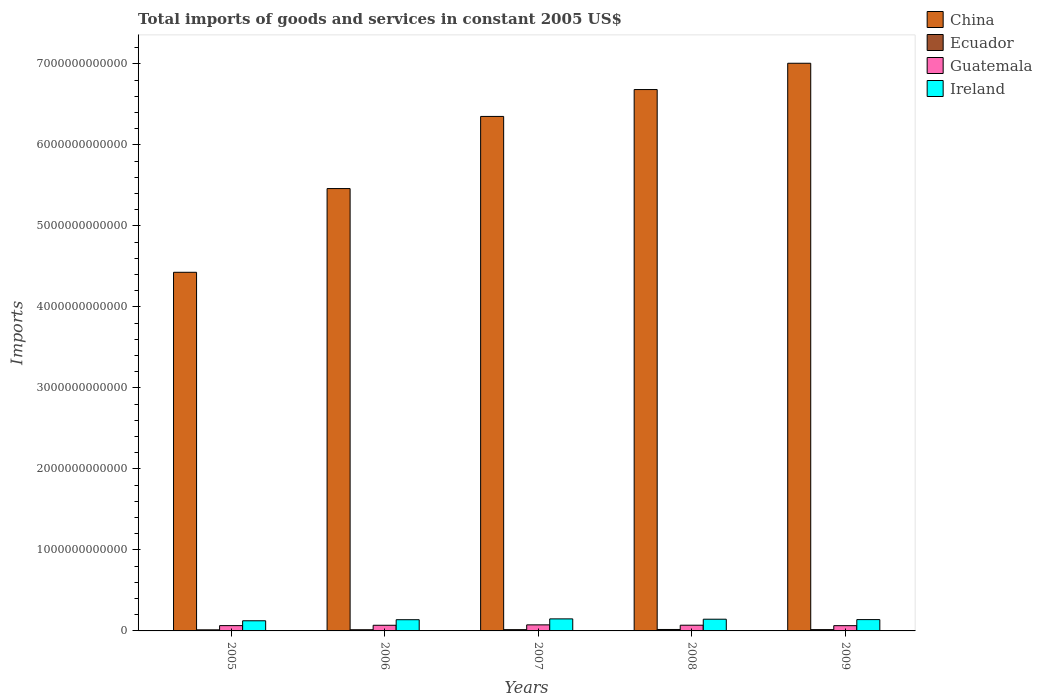How many different coloured bars are there?
Provide a succinct answer. 4. How many groups of bars are there?
Your answer should be very brief. 5. Are the number of bars per tick equal to the number of legend labels?
Make the answer very short. Yes. Are the number of bars on each tick of the X-axis equal?
Your answer should be compact. Yes. How many bars are there on the 3rd tick from the right?
Your answer should be very brief. 4. In how many cases, is the number of bars for a given year not equal to the number of legend labels?
Offer a very short reply. 0. What is the total imports of goods and services in Ecuador in 2005?
Provide a succinct answer. 1.33e+1. Across all years, what is the maximum total imports of goods and services in Guatemala?
Your answer should be very brief. 7.47e+1. Across all years, what is the minimum total imports of goods and services in Ireland?
Provide a short and direct response. 1.25e+11. In which year was the total imports of goods and services in Ireland maximum?
Make the answer very short. 2007. What is the total total imports of goods and services in Guatemala in the graph?
Your response must be concise. 3.45e+11. What is the difference between the total imports of goods and services in Ireland in 2008 and that in 2009?
Keep it short and to the point. 4.70e+09. What is the difference between the total imports of goods and services in China in 2007 and the total imports of goods and services in Ecuador in 2005?
Provide a succinct answer. 6.34e+12. What is the average total imports of goods and services in Ireland per year?
Keep it short and to the point. 1.39e+11. In the year 2009, what is the difference between the total imports of goods and services in China and total imports of goods and services in Ireland?
Offer a terse response. 6.87e+12. In how many years, is the total imports of goods and services in Ireland greater than 3000000000000 US$?
Ensure brevity in your answer.  0. What is the ratio of the total imports of goods and services in Ireland in 2006 to that in 2009?
Your answer should be compact. 0.99. Is the difference between the total imports of goods and services in China in 2007 and 2008 greater than the difference between the total imports of goods and services in Ireland in 2007 and 2008?
Ensure brevity in your answer.  No. What is the difference between the highest and the second highest total imports of goods and services in Ireland?
Give a very brief answer. 4.06e+09. What is the difference between the highest and the lowest total imports of goods and services in China?
Provide a succinct answer. 2.58e+12. In how many years, is the total imports of goods and services in Ireland greater than the average total imports of goods and services in Ireland taken over all years?
Offer a terse response. 3. Is the sum of the total imports of goods and services in Ecuador in 2005 and 2008 greater than the maximum total imports of goods and services in Ireland across all years?
Your answer should be very brief. No. What does the 4th bar from the right in 2009 represents?
Your response must be concise. China. Are all the bars in the graph horizontal?
Keep it short and to the point. No. What is the difference between two consecutive major ticks on the Y-axis?
Offer a very short reply. 1.00e+12. Are the values on the major ticks of Y-axis written in scientific E-notation?
Offer a very short reply. No. Where does the legend appear in the graph?
Provide a short and direct response. Top right. How many legend labels are there?
Keep it short and to the point. 4. What is the title of the graph?
Provide a short and direct response. Total imports of goods and services in constant 2005 US$. Does "Colombia" appear as one of the legend labels in the graph?
Give a very brief answer. No. What is the label or title of the Y-axis?
Make the answer very short. Imports. What is the Imports of China in 2005?
Give a very brief answer. 4.43e+12. What is the Imports in Ecuador in 2005?
Your answer should be very brief. 1.33e+1. What is the Imports in Guatemala in 2005?
Ensure brevity in your answer.  6.55e+1. What is the Imports in Ireland in 2005?
Your response must be concise. 1.25e+11. What is the Imports of China in 2006?
Provide a succinct answer. 5.46e+12. What is the Imports in Ecuador in 2006?
Ensure brevity in your answer.  1.46e+1. What is the Imports in Guatemala in 2006?
Keep it short and to the point. 6.97e+1. What is the Imports in Ireland in 2006?
Provide a succinct answer. 1.38e+11. What is the Imports in China in 2007?
Provide a succinct answer. 6.35e+12. What is the Imports in Ecuador in 2007?
Your response must be concise. 1.56e+1. What is the Imports in Guatemala in 2007?
Offer a very short reply. 7.47e+1. What is the Imports of Ireland in 2007?
Keep it short and to the point. 1.49e+11. What is the Imports of China in 2008?
Make the answer very short. 6.68e+12. What is the Imports of Ecuador in 2008?
Keep it short and to the point. 1.79e+1. What is the Imports of Guatemala in 2008?
Your answer should be very brief. 7.04e+1. What is the Imports in Ireland in 2008?
Keep it short and to the point. 1.44e+11. What is the Imports in China in 2009?
Your response must be concise. 7.01e+12. What is the Imports in Ecuador in 2009?
Your response must be concise. 1.61e+1. What is the Imports of Guatemala in 2009?
Your answer should be very brief. 6.49e+1. What is the Imports of Ireland in 2009?
Offer a very short reply. 1.40e+11. Across all years, what is the maximum Imports in China?
Ensure brevity in your answer.  7.01e+12. Across all years, what is the maximum Imports in Ecuador?
Keep it short and to the point. 1.79e+1. Across all years, what is the maximum Imports of Guatemala?
Make the answer very short. 7.47e+1. Across all years, what is the maximum Imports of Ireland?
Give a very brief answer. 1.49e+11. Across all years, what is the minimum Imports of China?
Your answer should be compact. 4.43e+12. Across all years, what is the minimum Imports of Ecuador?
Offer a terse response. 1.33e+1. Across all years, what is the minimum Imports in Guatemala?
Provide a short and direct response. 6.49e+1. Across all years, what is the minimum Imports of Ireland?
Provide a succinct answer. 1.25e+11. What is the total Imports of China in the graph?
Your answer should be compact. 2.99e+13. What is the total Imports in Ecuador in the graph?
Your answer should be compact. 7.76e+1. What is the total Imports in Guatemala in the graph?
Keep it short and to the point. 3.45e+11. What is the total Imports of Ireland in the graph?
Your response must be concise. 6.96e+11. What is the difference between the Imports in China in 2005 and that in 2006?
Offer a very short reply. -1.03e+12. What is the difference between the Imports of Ecuador in 2005 and that in 2006?
Offer a terse response. -1.30e+09. What is the difference between the Imports in Guatemala in 2005 and that in 2006?
Your answer should be compact. -4.22e+09. What is the difference between the Imports of Ireland in 2005 and that in 2006?
Make the answer very short. -1.32e+1. What is the difference between the Imports in China in 2005 and that in 2007?
Make the answer very short. -1.92e+12. What is the difference between the Imports in Ecuador in 2005 and that in 2007?
Make the answer very short. -2.33e+09. What is the difference between the Imports in Guatemala in 2005 and that in 2007?
Provide a succinct answer. -9.26e+09. What is the difference between the Imports in Ireland in 2005 and that in 2007?
Give a very brief answer. -2.34e+1. What is the difference between the Imports in China in 2005 and that in 2008?
Your answer should be very brief. -2.26e+12. What is the difference between the Imports of Ecuador in 2005 and that in 2008?
Provide a short and direct response. -4.59e+09. What is the difference between the Imports in Guatemala in 2005 and that in 2008?
Make the answer very short. -4.97e+09. What is the difference between the Imports in Ireland in 2005 and that in 2008?
Keep it short and to the point. -1.93e+1. What is the difference between the Imports in China in 2005 and that in 2009?
Your response must be concise. -2.58e+12. What is the difference between the Imports of Ecuador in 2005 and that in 2009?
Keep it short and to the point. -2.81e+09. What is the difference between the Imports of Guatemala in 2005 and that in 2009?
Your answer should be compact. 5.25e+08. What is the difference between the Imports of Ireland in 2005 and that in 2009?
Provide a short and direct response. -1.46e+1. What is the difference between the Imports of China in 2006 and that in 2007?
Provide a succinct answer. -8.91e+11. What is the difference between the Imports of Ecuador in 2006 and that in 2007?
Keep it short and to the point. -1.03e+09. What is the difference between the Imports of Guatemala in 2006 and that in 2007?
Offer a terse response. -5.04e+09. What is the difference between the Imports of Ireland in 2006 and that in 2007?
Keep it short and to the point. -1.02e+1. What is the difference between the Imports in China in 2006 and that in 2008?
Give a very brief answer. -1.22e+12. What is the difference between the Imports of Ecuador in 2006 and that in 2008?
Make the answer very short. -3.29e+09. What is the difference between the Imports in Guatemala in 2006 and that in 2008?
Offer a very short reply. -7.47e+08. What is the difference between the Imports in Ireland in 2006 and that in 2008?
Give a very brief answer. -6.09e+09. What is the difference between the Imports of China in 2006 and that in 2009?
Give a very brief answer. -1.55e+12. What is the difference between the Imports of Ecuador in 2006 and that in 2009?
Provide a succinct answer. -1.51e+09. What is the difference between the Imports of Guatemala in 2006 and that in 2009?
Ensure brevity in your answer.  4.75e+09. What is the difference between the Imports of Ireland in 2006 and that in 2009?
Offer a very short reply. -1.40e+09. What is the difference between the Imports in China in 2007 and that in 2008?
Provide a short and direct response. -3.32e+11. What is the difference between the Imports of Ecuador in 2007 and that in 2008?
Keep it short and to the point. -2.26e+09. What is the difference between the Imports of Guatemala in 2007 and that in 2008?
Ensure brevity in your answer.  4.29e+09. What is the difference between the Imports of Ireland in 2007 and that in 2008?
Ensure brevity in your answer.  4.06e+09. What is the difference between the Imports in China in 2007 and that in 2009?
Ensure brevity in your answer.  -6.56e+11. What is the difference between the Imports of Ecuador in 2007 and that in 2009?
Provide a short and direct response. -4.83e+08. What is the difference between the Imports of Guatemala in 2007 and that in 2009?
Offer a very short reply. 9.79e+09. What is the difference between the Imports of Ireland in 2007 and that in 2009?
Ensure brevity in your answer.  8.76e+09. What is the difference between the Imports in China in 2008 and that in 2009?
Make the answer very short. -3.25e+11. What is the difference between the Imports in Ecuador in 2008 and that in 2009?
Provide a short and direct response. 1.78e+09. What is the difference between the Imports in Guatemala in 2008 and that in 2009?
Give a very brief answer. 5.49e+09. What is the difference between the Imports of Ireland in 2008 and that in 2009?
Provide a succinct answer. 4.70e+09. What is the difference between the Imports in China in 2005 and the Imports in Ecuador in 2006?
Keep it short and to the point. 4.41e+12. What is the difference between the Imports in China in 2005 and the Imports in Guatemala in 2006?
Keep it short and to the point. 4.36e+12. What is the difference between the Imports of China in 2005 and the Imports of Ireland in 2006?
Ensure brevity in your answer.  4.29e+12. What is the difference between the Imports in Ecuador in 2005 and the Imports in Guatemala in 2006?
Keep it short and to the point. -5.64e+1. What is the difference between the Imports of Ecuador in 2005 and the Imports of Ireland in 2006?
Give a very brief answer. -1.25e+11. What is the difference between the Imports of Guatemala in 2005 and the Imports of Ireland in 2006?
Your answer should be compact. -7.29e+1. What is the difference between the Imports in China in 2005 and the Imports in Ecuador in 2007?
Your answer should be compact. 4.41e+12. What is the difference between the Imports in China in 2005 and the Imports in Guatemala in 2007?
Offer a terse response. 4.35e+12. What is the difference between the Imports of China in 2005 and the Imports of Ireland in 2007?
Your answer should be compact. 4.28e+12. What is the difference between the Imports of Ecuador in 2005 and the Imports of Guatemala in 2007?
Keep it short and to the point. -6.14e+1. What is the difference between the Imports in Ecuador in 2005 and the Imports in Ireland in 2007?
Your response must be concise. -1.35e+11. What is the difference between the Imports in Guatemala in 2005 and the Imports in Ireland in 2007?
Make the answer very short. -8.31e+1. What is the difference between the Imports in China in 2005 and the Imports in Ecuador in 2008?
Provide a short and direct response. 4.41e+12. What is the difference between the Imports in China in 2005 and the Imports in Guatemala in 2008?
Your answer should be compact. 4.36e+12. What is the difference between the Imports in China in 2005 and the Imports in Ireland in 2008?
Offer a terse response. 4.28e+12. What is the difference between the Imports of Ecuador in 2005 and the Imports of Guatemala in 2008?
Ensure brevity in your answer.  -5.71e+1. What is the difference between the Imports of Ecuador in 2005 and the Imports of Ireland in 2008?
Offer a very short reply. -1.31e+11. What is the difference between the Imports of Guatemala in 2005 and the Imports of Ireland in 2008?
Your answer should be very brief. -7.90e+1. What is the difference between the Imports in China in 2005 and the Imports in Ecuador in 2009?
Give a very brief answer. 4.41e+12. What is the difference between the Imports in China in 2005 and the Imports in Guatemala in 2009?
Your response must be concise. 4.36e+12. What is the difference between the Imports in China in 2005 and the Imports in Ireland in 2009?
Offer a terse response. 4.29e+12. What is the difference between the Imports of Ecuador in 2005 and the Imports of Guatemala in 2009?
Your answer should be compact. -5.16e+1. What is the difference between the Imports in Ecuador in 2005 and the Imports in Ireland in 2009?
Provide a succinct answer. -1.26e+11. What is the difference between the Imports of Guatemala in 2005 and the Imports of Ireland in 2009?
Ensure brevity in your answer.  -7.43e+1. What is the difference between the Imports of China in 2006 and the Imports of Ecuador in 2007?
Your answer should be compact. 5.44e+12. What is the difference between the Imports of China in 2006 and the Imports of Guatemala in 2007?
Your answer should be compact. 5.39e+12. What is the difference between the Imports in China in 2006 and the Imports in Ireland in 2007?
Provide a succinct answer. 5.31e+12. What is the difference between the Imports of Ecuador in 2006 and the Imports of Guatemala in 2007?
Give a very brief answer. -6.01e+1. What is the difference between the Imports of Ecuador in 2006 and the Imports of Ireland in 2007?
Give a very brief answer. -1.34e+11. What is the difference between the Imports in Guatemala in 2006 and the Imports in Ireland in 2007?
Offer a terse response. -7.89e+1. What is the difference between the Imports in China in 2006 and the Imports in Ecuador in 2008?
Your answer should be compact. 5.44e+12. What is the difference between the Imports of China in 2006 and the Imports of Guatemala in 2008?
Provide a short and direct response. 5.39e+12. What is the difference between the Imports in China in 2006 and the Imports in Ireland in 2008?
Offer a terse response. 5.32e+12. What is the difference between the Imports in Ecuador in 2006 and the Imports in Guatemala in 2008?
Your response must be concise. -5.58e+1. What is the difference between the Imports in Ecuador in 2006 and the Imports in Ireland in 2008?
Ensure brevity in your answer.  -1.30e+11. What is the difference between the Imports of Guatemala in 2006 and the Imports of Ireland in 2008?
Provide a succinct answer. -7.48e+1. What is the difference between the Imports of China in 2006 and the Imports of Ecuador in 2009?
Keep it short and to the point. 5.44e+12. What is the difference between the Imports of China in 2006 and the Imports of Guatemala in 2009?
Your answer should be very brief. 5.40e+12. What is the difference between the Imports in China in 2006 and the Imports in Ireland in 2009?
Your response must be concise. 5.32e+12. What is the difference between the Imports of Ecuador in 2006 and the Imports of Guatemala in 2009?
Keep it short and to the point. -5.03e+1. What is the difference between the Imports of Ecuador in 2006 and the Imports of Ireland in 2009?
Give a very brief answer. -1.25e+11. What is the difference between the Imports in Guatemala in 2006 and the Imports in Ireland in 2009?
Offer a very short reply. -7.01e+1. What is the difference between the Imports of China in 2007 and the Imports of Ecuador in 2008?
Give a very brief answer. 6.33e+12. What is the difference between the Imports in China in 2007 and the Imports in Guatemala in 2008?
Keep it short and to the point. 6.28e+12. What is the difference between the Imports in China in 2007 and the Imports in Ireland in 2008?
Offer a terse response. 6.21e+12. What is the difference between the Imports of Ecuador in 2007 and the Imports of Guatemala in 2008?
Offer a terse response. -5.48e+1. What is the difference between the Imports in Ecuador in 2007 and the Imports in Ireland in 2008?
Your answer should be very brief. -1.29e+11. What is the difference between the Imports in Guatemala in 2007 and the Imports in Ireland in 2008?
Keep it short and to the point. -6.98e+1. What is the difference between the Imports in China in 2007 and the Imports in Ecuador in 2009?
Your answer should be compact. 6.34e+12. What is the difference between the Imports in China in 2007 and the Imports in Guatemala in 2009?
Offer a terse response. 6.29e+12. What is the difference between the Imports of China in 2007 and the Imports of Ireland in 2009?
Your answer should be compact. 6.21e+12. What is the difference between the Imports of Ecuador in 2007 and the Imports of Guatemala in 2009?
Ensure brevity in your answer.  -4.93e+1. What is the difference between the Imports of Ecuador in 2007 and the Imports of Ireland in 2009?
Your response must be concise. -1.24e+11. What is the difference between the Imports in Guatemala in 2007 and the Imports in Ireland in 2009?
Provide a succinct answer. -6.51e+1. What is the difference between the Imports of China in 2008 and the Imports of Ecuador in 2009?
Offer a very short reply. 6.67e+12. What is the difference between the Imports of China in 2008 and the Imports of Guatemala in 2009?
Provide a succinct answer. 6.62e+12. What is the difference between the Imports in China in 2008 and the Imports in Ireland in 2009?
Give a very brief answer. 6.54e+12. What is the difference between the Imports of Ecuador in 2008 and the Imports of Guatemala in 2009?
Provide a succinct answer. -4.70e+1. What is the difference between the Imports of Ecuador in 2008 and the Imports of Ireland in 2009?
Provide a succinct answer. -1.22e+11. What is the difference between the Imports in Guatemala in 2008 and the Imports in Ireland in 2009?
Offer a very short reply. -6.94e+1. What is the average Imports of China per year?
Provide a succinct answer. 5.99e+12. What is the average Imports of Ecuador per year?
Your response must be concise. 1.55e+1. What is the average Imports of Guatemala per year?
Provide a short and direct response. 6.90e+1. What is the average Imports of Ireland per year?
Your answer should be very brief. 1.39e+11. In the year 2005, what is the difference between the Imports of China and Imports of Ecuador?
Offer a terse response. 4.41e+12. In the year 2005, what is the difference between the Imports in China and Imports in Guatemala?
Ensure brevity in your answer.  4.36e+12. In the year 2005, what is the difference between the Imports in China and Imports in Ireland?
Provide a succinct answer. 4.30e+12. In the year 2005, what is the difference between the Imports of Ecuador and Imports of Guatemala?
Your answer should be compact. -5.22e+1. In the year 2005, what is the difference between the Imports in Ecuador and Imports in Ireland?
Your answer should be compact. -1.12e+11. In the year 2005, what is the difference between the Imports of Guatemala and Imports of Ireland?
Give a very brief answer. -5.97e+1. In the year 2006, what is the difference between the Imports in China and Imports in Ecuador?
Provide a short and direct response. 5.45e+12. In the year 2006, what is the difference between the Imports in China and Imports in Guatemala?
Ensure brevity in your answer.  5.39e+12. In the year 2006, what is the difference between the Imports in China and Imports in Ireland?
Offer a very short reply. 5.32e+12. In the year 2006, what is the difference between the Imports in Ecuador and Imports in Guatemala?
Make the answer very short. -5.51e+1. In the year 2006, what is the difference between the Imports of Ecuador and Imports of Ireland?
Ensure brevity in your answer.  -1.24e+11. In the year 2006, what is the difference between the Imports in Guatemala and Imports in Ireland?
Give a very brief answer. -6.87e+1. In the year 2007, what is the difference between the Imports in China and Imports in Ecuador?
Provide a succinct answer. 6.34e+12. In the year 2007, what is the difference between the Imports of China and Imports of Guatemala?
Your answer should be compact. 6.28e+12. In the year 2007, what is the difference between the Imports in China and Imports in Ireland?
Keep it short and to the point. 6.20e+12. In the year 2007, what is the difference between the Imports in Ecuador and Imports in Guatemala?
Provide a short and direct response. -5.91e+1. In the year 2007, what is the difference between the Imports of Ecuador and Imports of Ireland?
Give a very brief answer. -1.33e+11. In the year 2007, what is the difference between the Imports of Guatemala and Imports of Ireland?
Your answer should be very brief. -7.38e+1. In the year 2008, what is the difference between the Imports in China and Imports in Ecuador?
Give a very brief answer. 6.66e+12. In the year 2008, what is the difference between the Imports in China and Imports in Guatemala?
Your answer should be compact. 6.61e+12. In the year 2008, what is the difference between the Imports of China and Imports of Ireland?
Make the answer very short. 6.54e+12. In the year 2008, what is the difference between the Imports in Ecuador and Imports in Guatemala?
Give a very brief answer. -5.25e+1. In the year 2008, what is the difference between the Imports of Ecuador and Imports of Ireland?
Your answer should be compact. -1.27e+11. In the year 2008, what is the difference between the Imports in Guatemala and Imports in Ireland?
Keep it short and to the point. -7.41e+1. In the year 2009, what is the difference between the Imports of China and Imports of Ecuador?
Make the answer very short. 6.99e+12. In the year 2009, what is the difference between the Imports in China and Imports in Guatemala?
Offer a very short reply. 6.94e+12. In the year 2009, what is the difference between the Imports in China and Imports in Ireland?
Provide a succinct answer. 6.87e+12. In the year 2009, what is the difference between the Imports of Ecuador and Imports of Guatemala?
Your answer should be compact. -4.88e+1. In the year 2009, what is the difference between the Imports of Ecuador and Imports of Ireland?
Offer a very short reply. -1.24e+11. In the year 2009, what is the difference between the Imports in Guatemala and Imports in Ireland?
Offer a terse response. -7.49e+1. What is the ratio of the Imports in China in 2005 to that in 2006?
Your answer should be very brief. 0.81. What is the ratio of the Imports of Ecuador in 2005 to that in 2006?
Give a very brief answer. 0.91. What is the ratio of the Imports in Guatemala in 2005 to that in 2006?
Your answer should be compact. 0.94. What is the ratio of the Imports in Ireland in 2005 to that in 2006?
Make the answer very short. 0.9. What is the ratio of the Imports in China in 2005 to that in 2007?
Your answer should be very brief. 0.7. What is the ratio of the Imports in Ecuador in 2005 to that in 2007?
Your answer should be very brief. 0.85. What is the ratio of the Imports in Guatemala in 2005 to that in 2007?
Ensure brevity in your answer.  0.88. What is the ratio of the Imports of Ireland in 2005 to that in 2007?
Give a very brief answer. 0.84. What is the ratio of the Imports in China in 2005 to that in 2008?
Give a very brief answer. 0.66. What is the ratio of the Imports in Ecuador in 2005 to that in 2008?
Offer a very short reply. 0.74. What is the ratio of the Imports in Guatemala in 2005 to that in 2008?
Keep it short and to the point. 0.93. What is the ratio of the Imports in Ireland in 2005 to that in 2008?
Provide a short and direct response. 0.87. What is the ratio of the Imports of China in 2005 to that in 2009?
Make the answer very short. 0.63. What is the ratio of the Imports in Ecuador in 2005 to that in 2009?
Provide a succinct answer. 0.83. What is the ratio of the Imports of Guatemala in 2005 to that in 2009?
Keep it short and to the point. 1.01. What is the ratio of the Imports of Ireland in 2005 to that in 2009?
Your response must be concise. 0.9. What is the ratio of the Imports in China in 2006 to that in 2007?
Keep it short and to the point. 0.86. What is the ratio of the Imports of Ecuador in 2006 to that in 2007?
Ensure brevity in your answer.  0.93. What is the ratio of the Imports of Guatemala in 2006 to that in 2007?
Keep it short and to the point. 0.93. What is the ratio of the Imports of Ireland in 2006 to that in 2007?
Provide a succinct answer. 0.93. What is the ratio of the Imports in China in 2006 to that in 2008?
Keep it short and to the point. 0.82. What is the ratio of the Imports in Ecuador in 2006 to that in 2008?
Provide a succinct answer. 0.82. What is the ratio of the Imports in Ireland in 2006 to that in 2008?
Make the answer very short. 0.96. What is the ratio of the Imports of China in 2006 to that in 2009?
Keep it short and to the point. 0.78. What is the ratio of the Imports of Ecuador in 2006 to that in 2009?
Provide a succinct answer. 0.91. What is the ratio of the Imports in Guatemala in 2006 to that in 2009?
Your answer should be very brief. 1.07. What is the ratio of the Imports of China in 2007 to that in 2008?
Provide a succinct answer. 0.95. What is the ratio of the Imports of Ecuador in 2007 to that in 2008?
Give a very brief answer. 0.87. What is the ratio of the Imports in Guatemala in 2007 to that in 2008?
Give a very brief answer. 1.06. What is the ratio of the Imports in Ireland in 2007 to that in 2008?
Provide a succinct answer. 1.03. What is the ratio of the Imports of China in 2007 to that in 2009?
Make the answer very short. 0.91. What is the ratio of the Imports of Ecuador in 2007 to that in 2009?
Provide a short and direct response. 0.97. What is the ratio of the Imports in Guatemala in 2007 to that in 2009?
Your response must be concise. 1.15. What is the ratio of the Imports of Ireland in 2007 to that in 2009?
Offer a terse response. 1.06. What is the ratio of the Imports of China in 2008 to that in 2009?
Give a very brief answer. 0.95. What is the ratio of the Imports of Ecuador in 2008 to that in 2009?
Make the answer very short. 1.11. What is the ratio of the Imports of Guatemala in 2008 to that in 2009?
Provide a succinct answer. 1.08. What is the ratio of the Imports in Ireland in 2008 to that in 2009?
Provide a succinct answer. 1.03. What is the difference between the highest and the second highest Imports in China?
Make the answer very short. 3.25e+11. What is the difference between the highest and the second highest Imports in Ecuador?
Provide a short and direct response. 1.78e+09. What is the difference between the highest and the second highest Imports of Guatemala?
Your answer should be very brief. 4.29e+09. What is the difference between the highest and the second highest Imports in Ireland?
Your response must be concise. 4.06e+09. What is the difference between the highest and the lowest Imports of China?
Your answer should be very brief. 2.58e+12. What is the difference between the highest and the lowest Imports in Ecuador?
Make the answer very short. 4.59e+09. What is the difference between the highest and the lowest Imports in Guatemala?
Your response must be concise. 9.79e+09. What is the difference between the highest and the lowest Imports in Ireland?
Keep it short and to the point. 2.34e+1. 